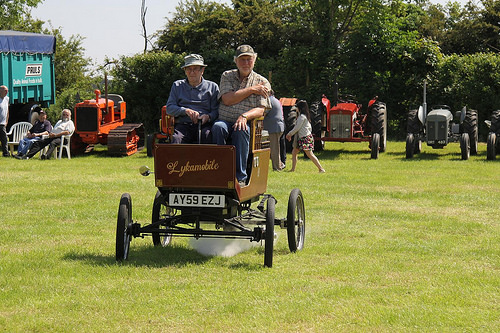<image>
Is the woman in the tractor? No. The woman is not contained within the tractor. These objects have a different spatial relationship. 